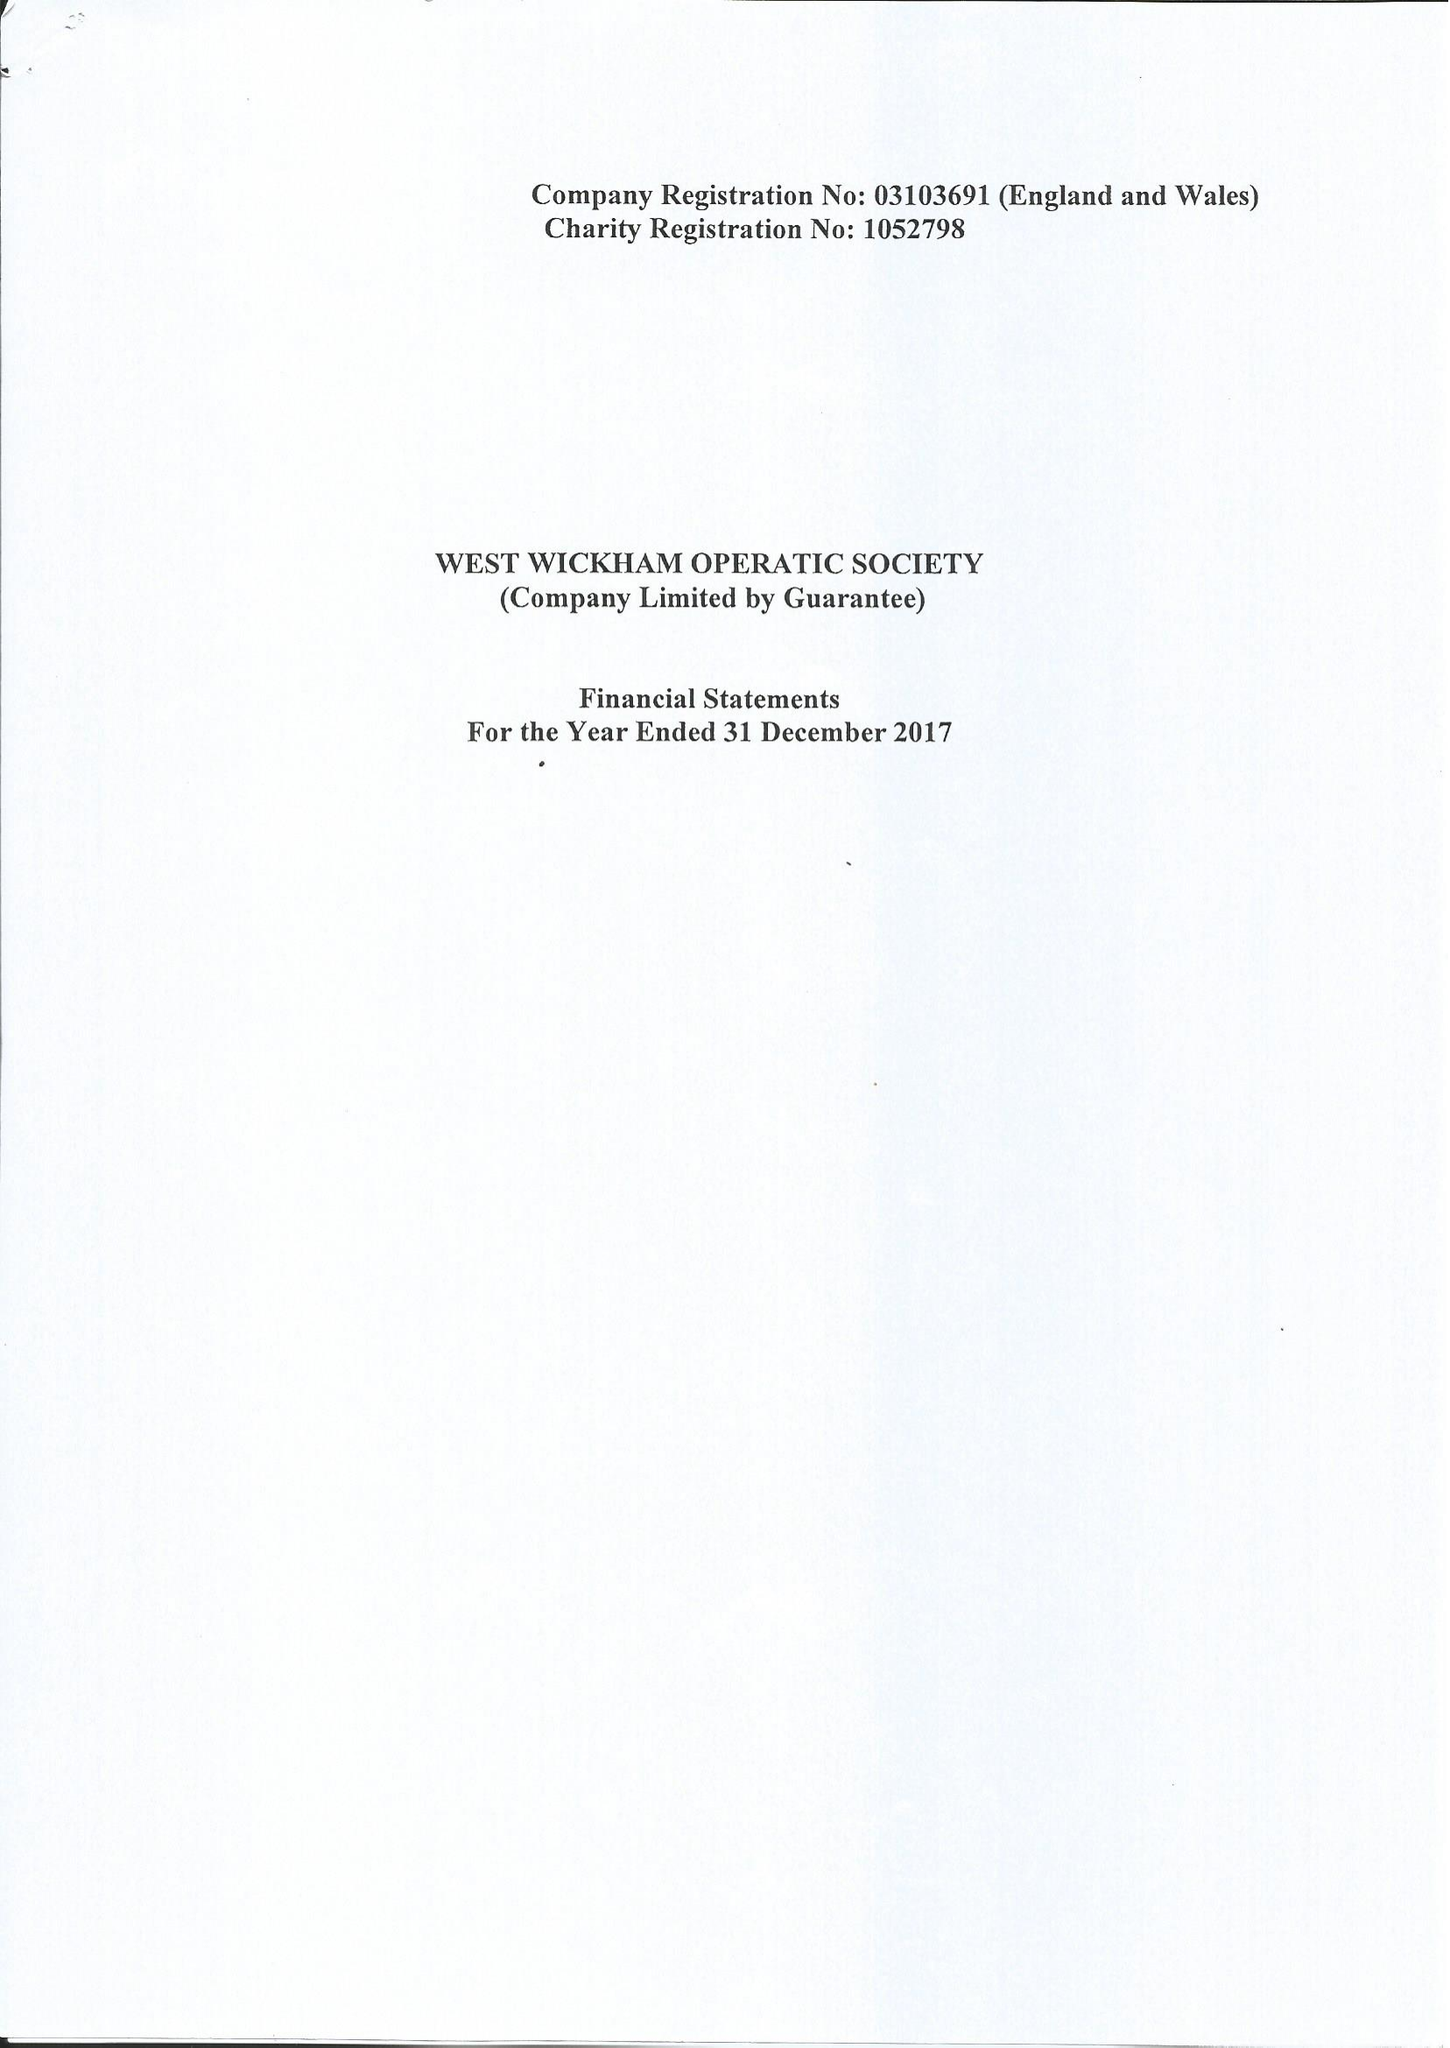What is the value for the address__postcode?
Answer the question using a single word or phrase. BR3 6LP 